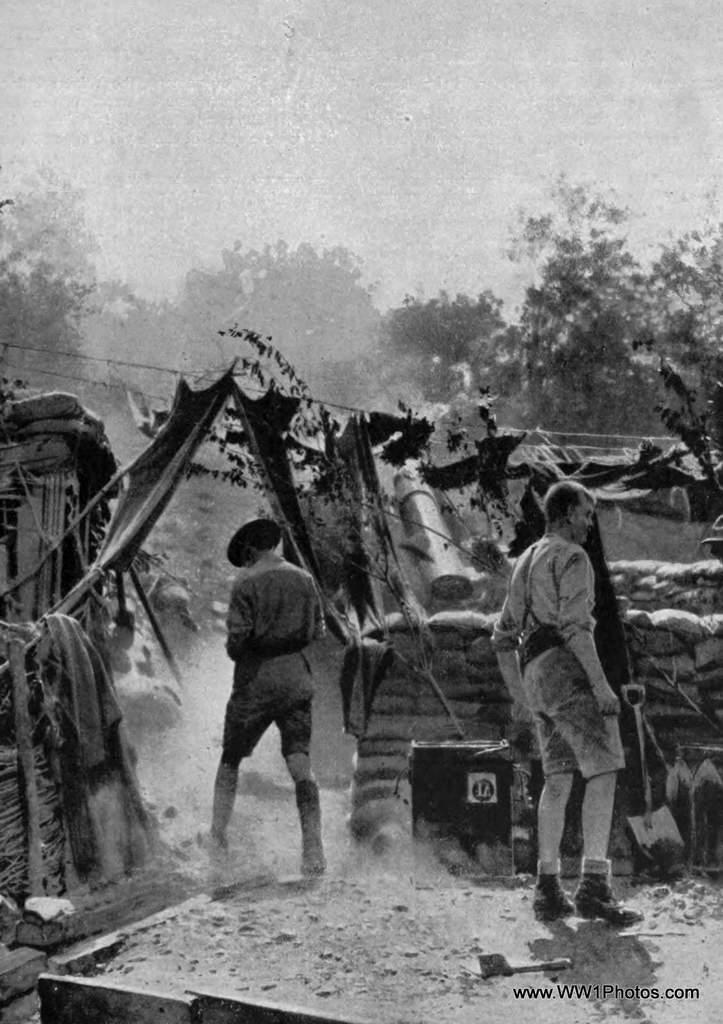How would you summarize this image in a sentence or two? This is a black and white image. In this image we can see men standing on the ground, shovel, sacs arranged in rows, cloth hanged to the rope, trees and sky. 